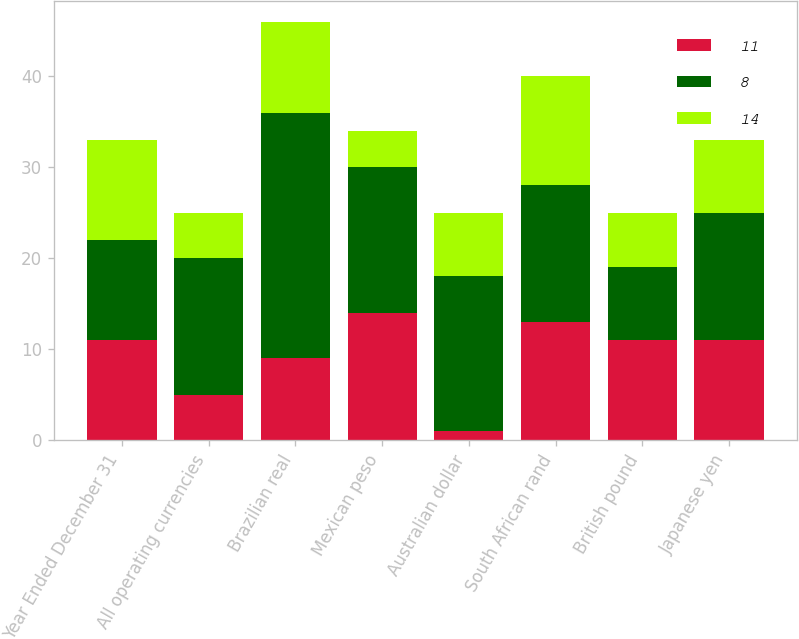<chart> <loc_0><loc_0><loc_500><loc_500><stacked_bar_chart><ecel><fcel>Year Ended December 31<fcel>All operating currencies<fcel>Brazilian real<fcel>Mexican peso<fcel>Australian dollar<fcel>South African rand<fcel>British pound<fcel>Japanese yen<nl><fcel>11<fcel>11<fcel>5<fcel>9<fcel>14<fcel>1<fcel>13<fcel>11<fcel>11<nl><fcel>8<fcel>11<fcel>15<fcel>27<fcel>16<fcel>17<fcel>15<fcel>8<fcel>14<nl><fcel>14<fcel>11<fcel>5<fcel>10<fcel>4<fcel>7<fcel>12<fcel>6<fcel>8<nl></chart> 